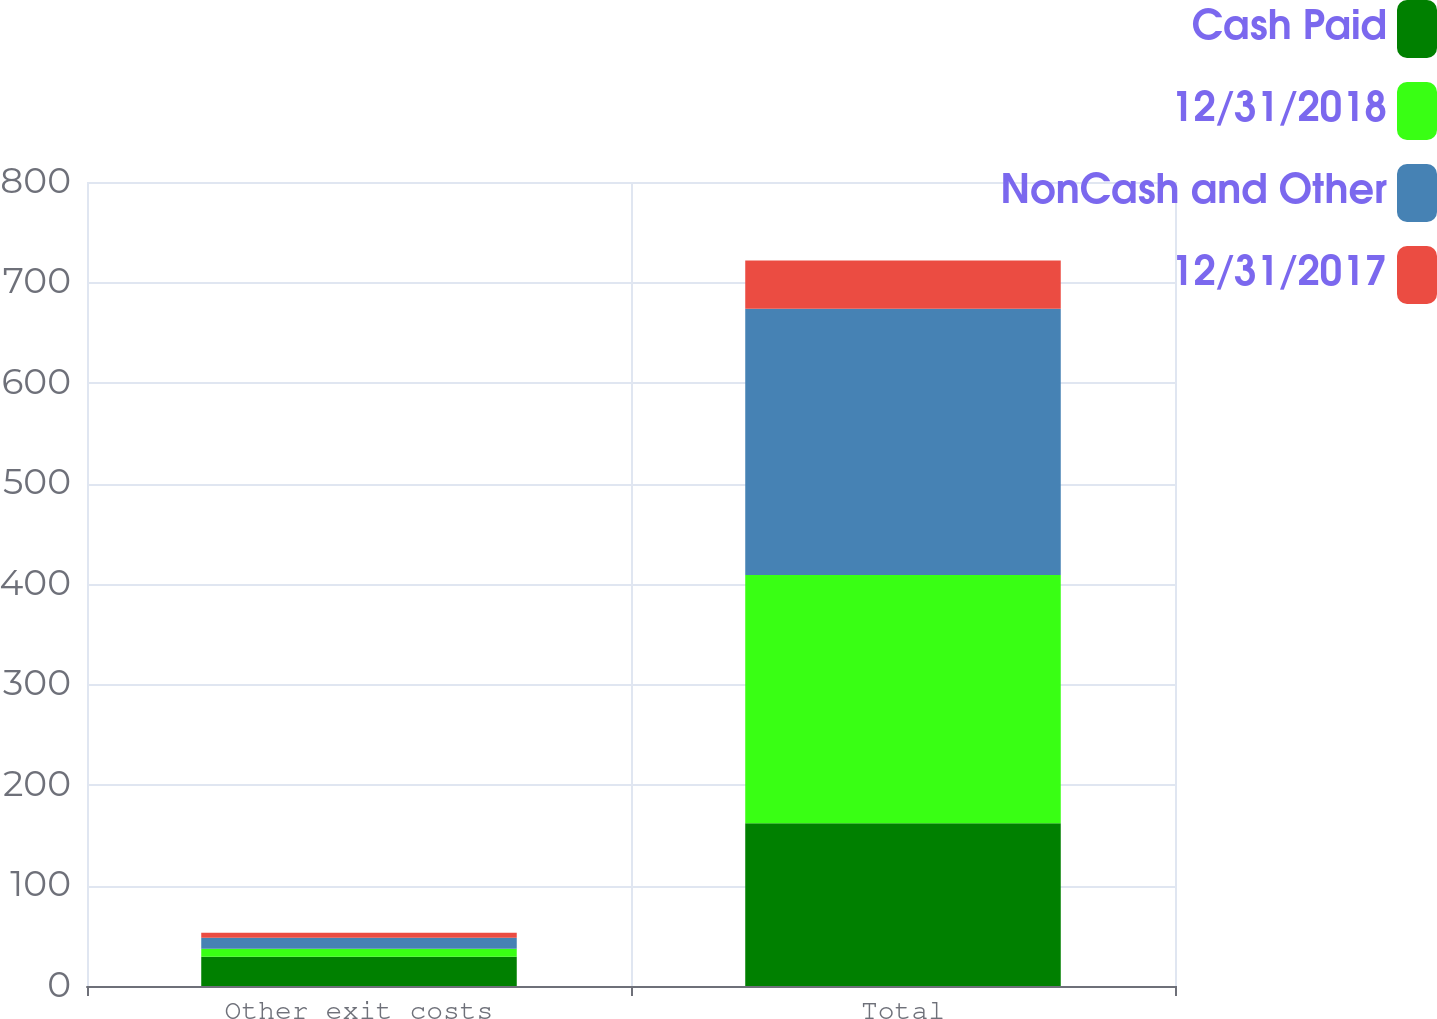<chart> <loc_0><loc_0><loc_500><loc_500><stacked_bar_chart><ecel><fcel>Other exit costs<fcel>Total<nl><fcel>Cash Paid<fcel>29<fcel>162<nl><fcel>12/31/2018<fcel>8<fcel>247<nl><fcel>NonCash and Other<fcel>11<fcel>265<nl><fcel>12/31/2017<fcel>5<fcel>48<nl></chart> 